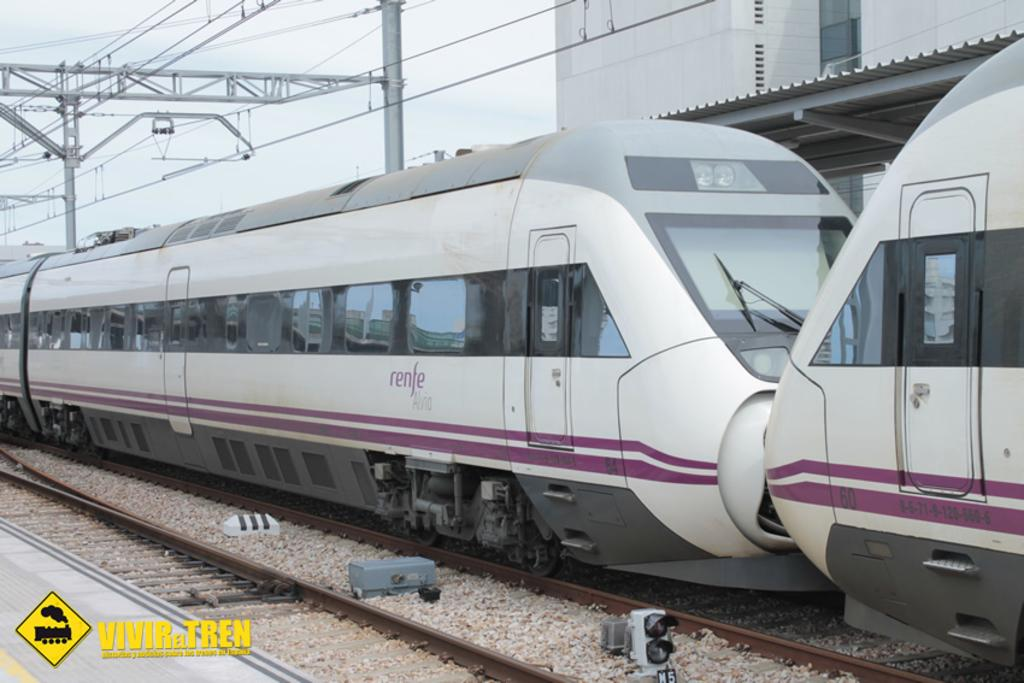<image>
Provide a brief description of the given image. A renfe train is on the tracks at a station. 